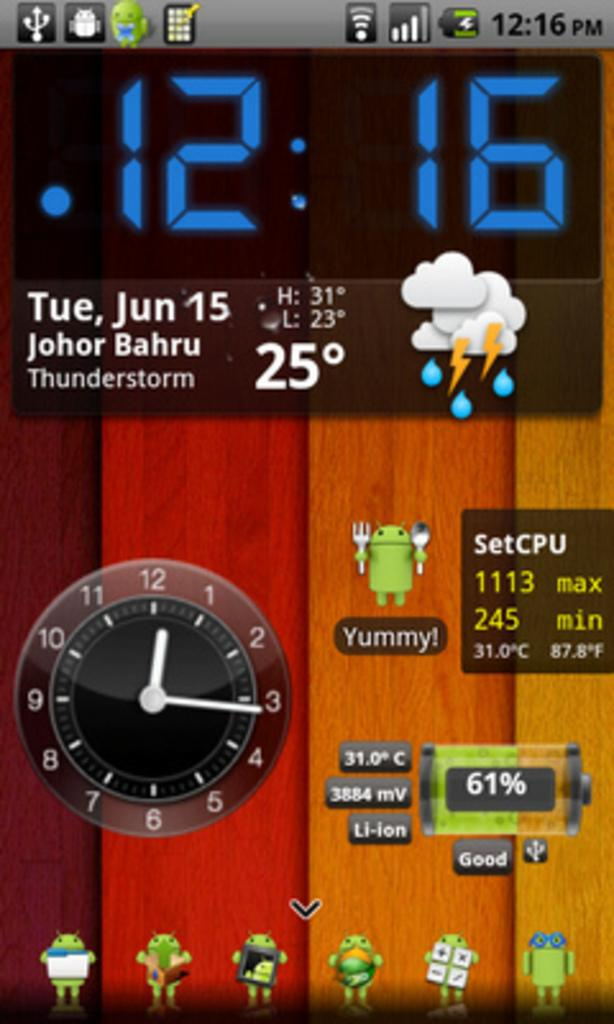<image>
Present a compact description of the photo's key features. smartphone screen that says 12:16 Tue, Jan 15, Johor Bahru Thunderstorm, 25 degrees. 